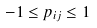<formula> <loc_0><loc_0><loc_500><loc_500>- 1 \leq p _ { i j } \leq 1</formula> 